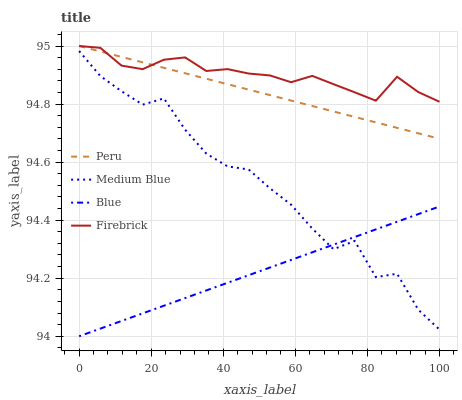Does Medium Blue have the minimum area under the curve?
Answer yes or no. No. Does Medium Blue have the maximum area under the curve?
Answer yes or no. No. Is Firebrick the smoothest?
Answer yes or no. No. Is Firebrick the roughest?
Answer yes or no. No. Does Medium Blue have the lowest value?
Answer yes or no. No. Does Medium Blue have the highest value?
Answer yes or no. No. Is Blue less than Firebrick?
Answer yes or no. Yes. Is Peru greater than Medium Blue?
Answer yes or no. Yes. Does Blue intersect Firebrick?
Answer yes or no. No. 